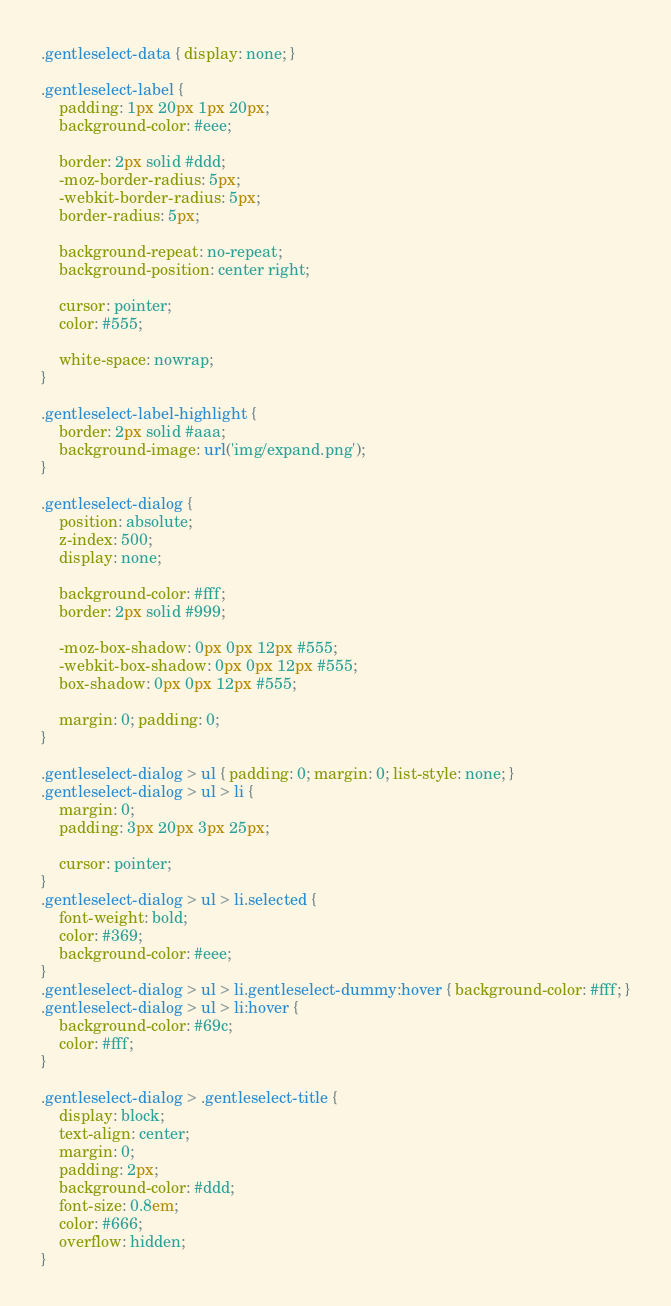Convert code to text. <code><loc_0><loc_0><loc_500><loc_500><_CSS_>.gentleselect-data { display: none; }

.gentleselect-label {
    padding: 1px 20px 1px 20px;
    background-color: #eee;
    
    border: 2px solid #ddd;
    -moz-border-radius: 5px;
    -webkit-border-radius: 5px;
    border-radius: 5px;   

    background-repeat: no-repeat; 
    background-position: center right; 
    
    cursor: pointer;
    color: #555;
    
    white-space: nowrap;
}

.gentleselect-label-highlight {
    border: 2px solid #aaa;
    background-image: url('img/expand.png');
}

.gentleselect-dialog {
    position: absolute;
    z-index: 500;
    display: none;

    background-color: #fff;
    border: 2px solid #999;

    -moz-box-shadow: 0px 0px 12px #555;
    -webkit-box-shadow: 0px 0px 12px #555;
    box-shadow: 0px 0px 12px #555;

    margin: 0; padding: 0;
}

.gentleselect-dialog > ul { padding: 0; margin: 0; list-style: none; }
.gentleselect-dialog > ul > li {
    margin: 0;
    padding: 3px 20px 3px 25px;
    
    cursor: pointer;
}
.gentleselect-dialog > ul > li.selected {
    font-weight: bold;
    color: #369;
    background-color: #eee;
}
.gentleselect-dialog > ul > li.gentleselect-dummy:hover { background-color: #fff; }
.gentleselect-dialog > ul > li:hover {
    background-color: #69c;
    color: #fff;
}

.gentleselect-dialog > .gentleselect-title {
    display: block;
    text-align: center;
    margin: 0;
    padding: 2px;
    background-color: #ddd;
    font-size: 0.8em;
    color: #666;
    overflow: hidden;
}</code> 